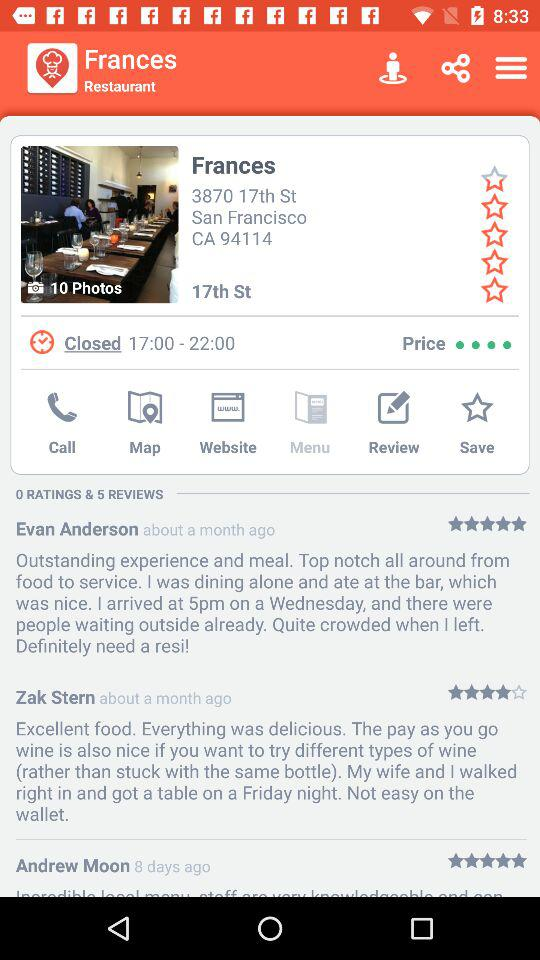How many stars are given by Zak Stern? There are 4 stars given by Zak Stern. 